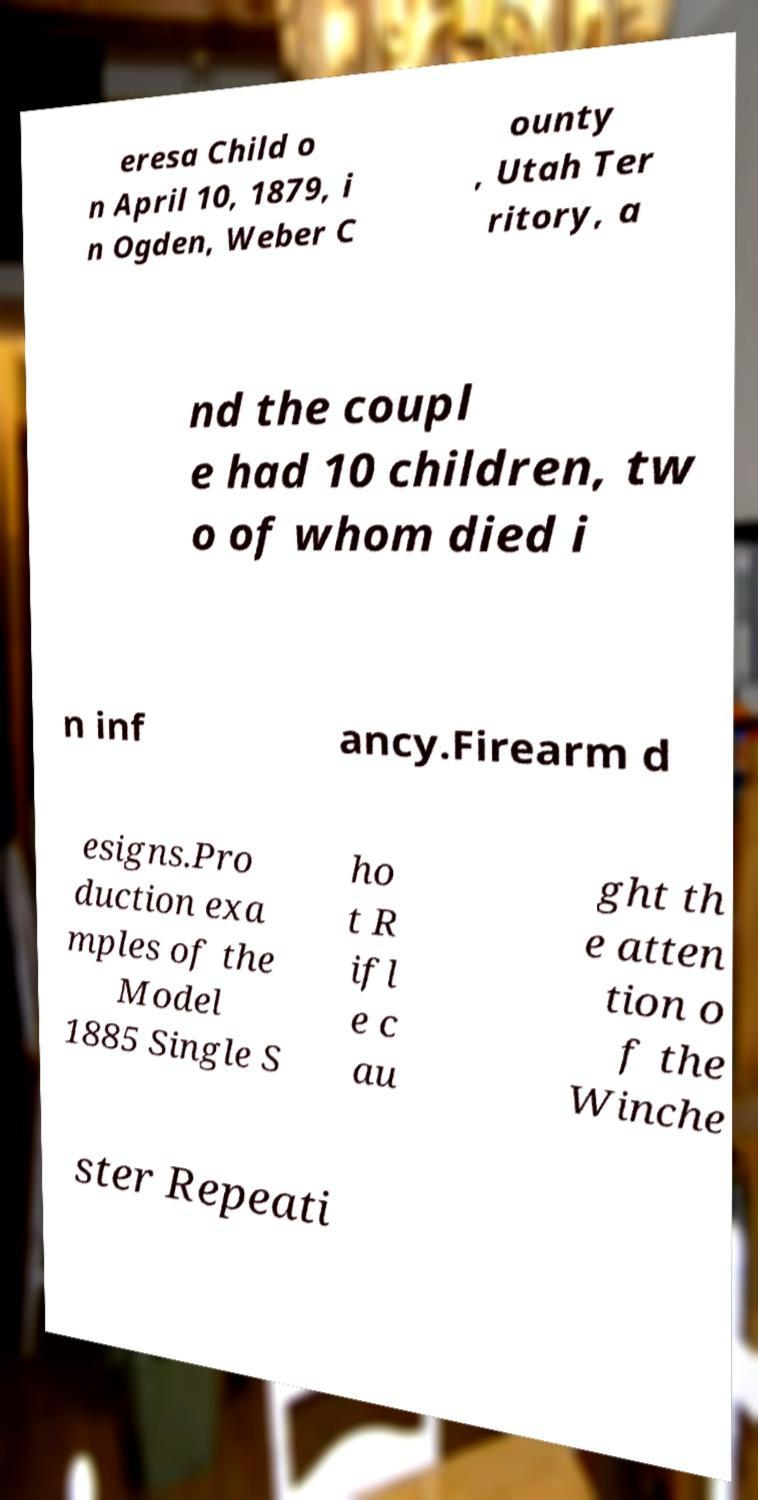Please identify and transcribe the text found in this image. eresa Child o n April 10, 1879, i n Ogden, Weber C ounty , Utah Ter ritory, a nd the coupl e had 10 children, tw o of whom died i n inf ancy.Firearm d esigns.Pro duction exa mples of the Model 1885 Single S ho t R ifl e c au ght th e atten tion o f the Winche ster Repeati 